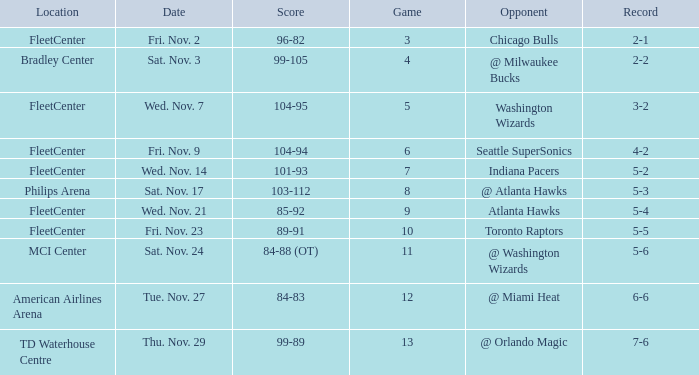What game has a score of 89-91? 10.0. Can you give me this table as a dict? {'header': ['Location', 'Date', 'Score', 'Game', 'Opponent', 'Record'], 'rows': [['FleetCenter', 'Fri. Nov. 2', '96-82', '3', 'Chicago Bulls', '2-1'], ['Bradley Center', 'Sat. Nov. 3', '99-105', '4', '@ Milwaukee Bucks', '2-2'], ['FleetCenter', 'Wed. Nov. 7', '104-95', '5', 'Washington Wizards', '3-2'], ['FleetCenter', 'Fri. Nov. 9', '104-94', '6', 'Seattle SuperSonics', '4-2'], ['FleetCenter', 'Wed. Nov. 14', '101-93', '7', 'Indiana Pacers', '5-2'], ['Philips Arena', 'Sat. Nov. 17', '103-112', '8', '@ Atlanta Hawks', '5-3'], ['FleetCenter', 'Wed. Nov. 21', '85-92', '9', 'Atlanta Hawks', '5-4'], ['FleetCenter', 'Fri. Nov. 23', '89-91', '10', 'Toronto Raptors', '5-5'], ['MCI Center', 'Sat. Nov. 24', '84-88 (OT)', '11', '@ Washington Wizards', '5-6'], ['American Airlines Arena', 'Tue. Nov. 27', '84-83', '12', '@ Miami Heat', '6-6'], ['TD Waterhouse Centre', 'Thu. Nov. 29', '99-89', '13', '@ Orlando Magic', '7-6']]} 